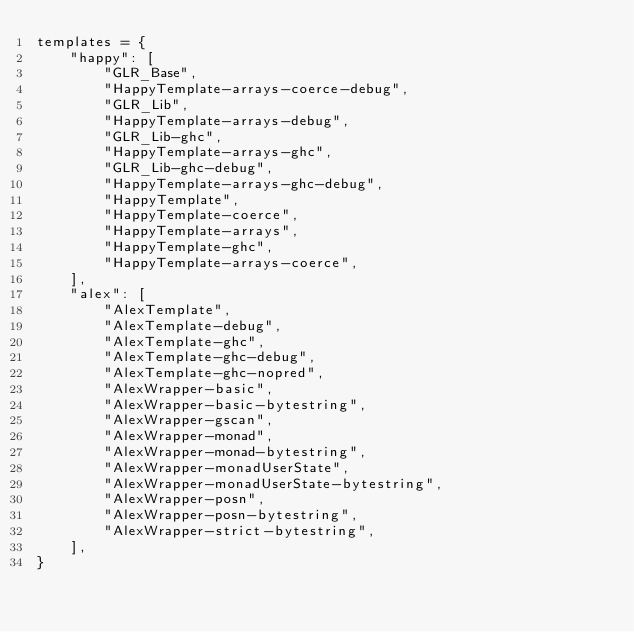Convert code to text. <code><loc_0><loc_0><loc_500><loc_500><_Python_>templates = {
    "happy": [
        "GLR_Base",
        "HappyTemplate-arrays-coerce-debug",
        "GLR_Lib",
        "HappyTemplate-arrays-debug",
        "GLR_Lib-ghc",
        "HappyTemplate-arrays-ghc",
        "GLR_Lib-ghc-debug",
        "HappyTemplate-arrays-ghc-debug",
        "HappyTemplate",
        "HappyTemplate-coerce",
        "HappyTemplate-arrays",
        "HappyTemplate-ghc",
        "HappyTemplate-arrays-coerce",
    ],
    "alex": [
        "AlexTemplate",
        "AlexTemplate-debug",
        "AlexTemplate-ghc",
        "AlexTemplate-ghc-debug",
        "AlexTemplate-ghc-nopred",
        "AlexWrapper-basic",
        "AlexWrapper-basic-bytestring",
        "AlexWrapper-gscan",
        "AlexWrapper-monad",
        "AlexWrapper-monad-bytestring",
        "AlexWrapper-monadUserState",
        "AlexWrapper-monadUserState-bytestring",
        "AlexWrapper-posn",
        "AlexWrapper-posn-bytestring",
        "AlexWrapper-strict-bytestring",
    ],
}
</code> 